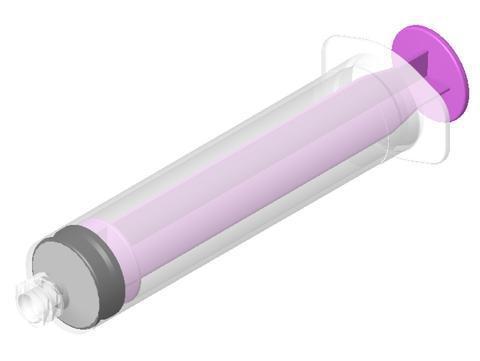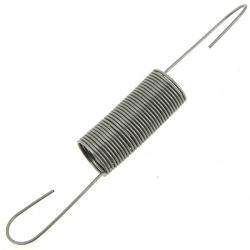The first image is the image on the left, the second image is the image on the right. For the images shown, is this caption "There is one purple syringe and one metal tool all sideways with the right side up." true? Answer yes or no. Yes. The first image is the image on the left, the second image is the image on the right. For the images displayed, is the sentence "The syringe is marked to contain up to 60ml." factually correct? Answer yes or no. No. 